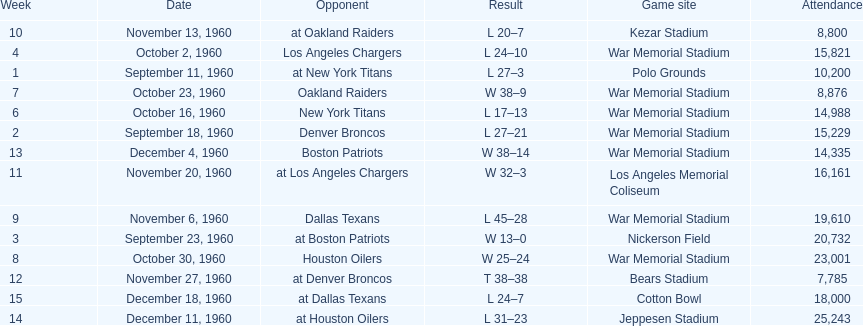What was the largest difference of points in a single game? 29. 